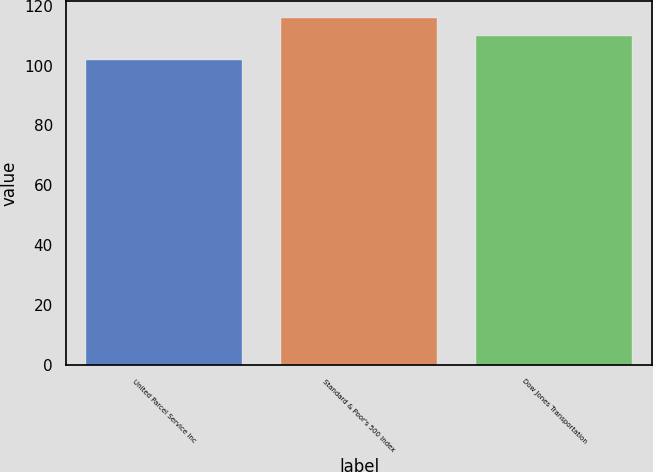<chart> <loc_0><loc_0><loc_500><loc_500><bar_chart><fcel>United Parcel Service Inc<fcel>Standard & Poor's 500 Index<fcel>Dow Jones Transportation<nl><fcel>101.76<fcel>115.79<fcel>109.82<nl></chart> 